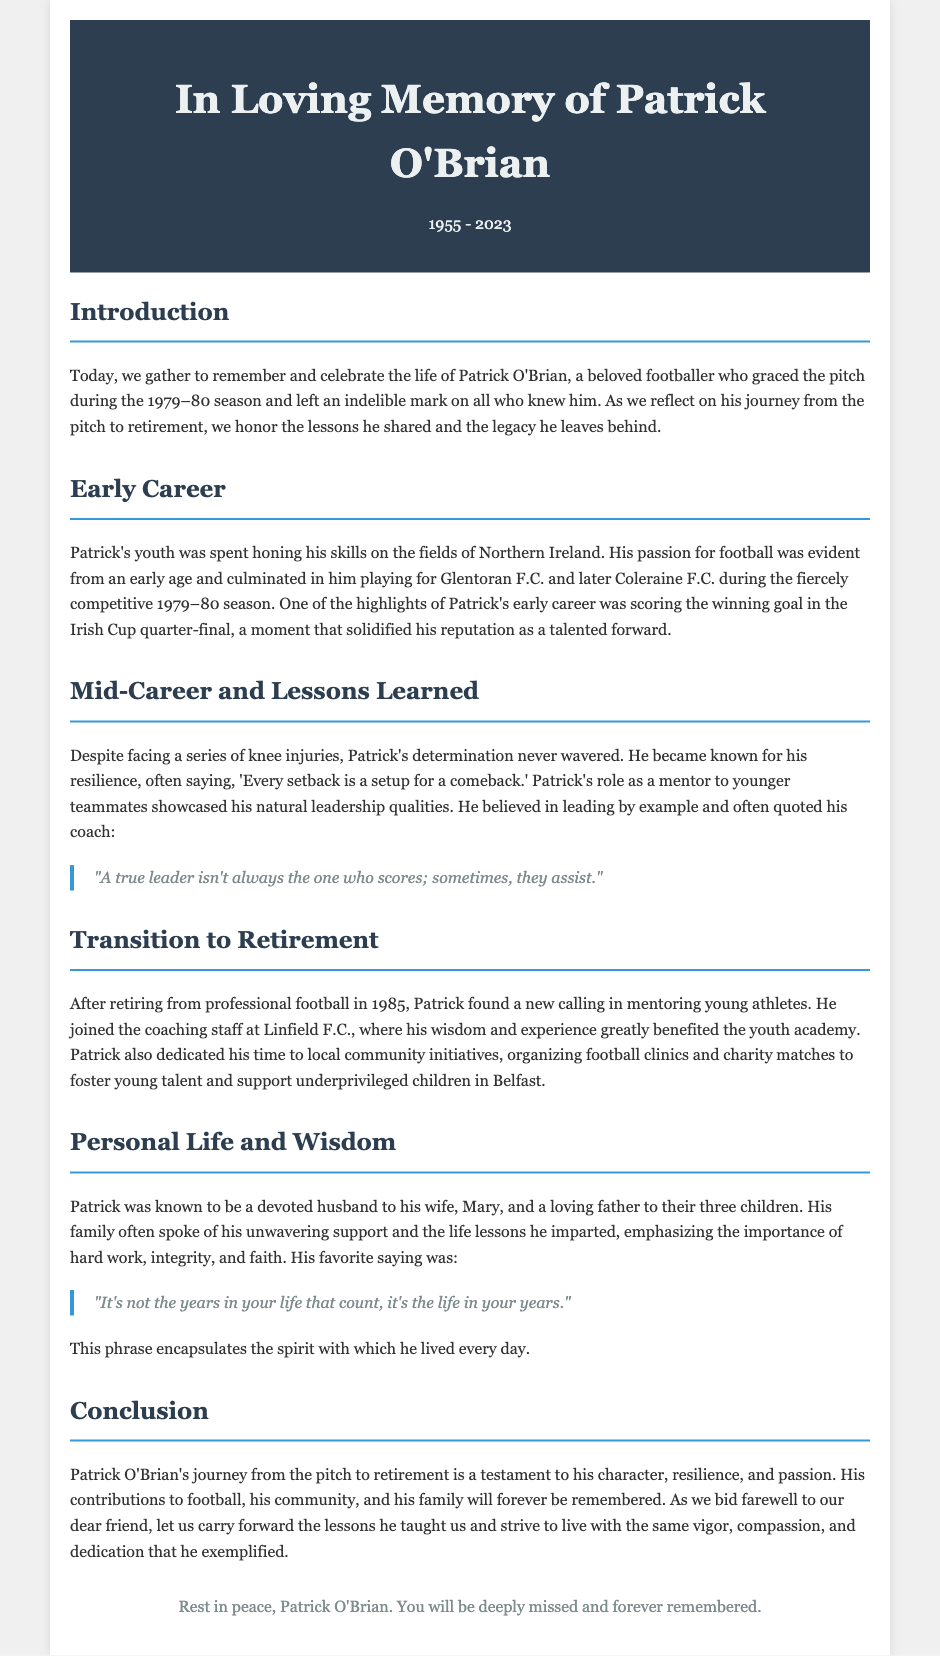What is the full name of the individual being remembered? The document provides the name of the individual, which is stated in the header.
Answer: Patrick O'Brian In which year did Patrick O'Brian play during the competitive season? The document mentions the specific season in the introductory section.
Answer: 1979–80 What was Patrick's role during his football career? The document describes Patrick's position on the field as a forward in his early career.
Answer: Forward What injury did Patrick face during his career? The document specifies the type of injuries Patrick dealt with that impacted his playing.
Answer: Knee injuries What quote did Patrick often say regarding setbacks? The document includes a specific quote attributed to Patrick about setbacks and comebacks.
Answer: "Every setback is a setup for a comeback." What did Patrick dedicate his time to after retiring from football? The document outlines Patrick's main focus after retirement, particularly in mentoring young athletes.
Answer: Mentoring young athletes Who was Patrick O'Brian's wife? The document recognizes Patrick's family as part of his personal life, including his spouse.
Answer: Mary What did Patrick consider important in life, as per his favorite saying? The document mentions a saying that encapsulates Patrick's view on life and its importance.
Answer: "It's not the years in your life that count, it's the life in your years." What is the document's purpose? The document serves a specific function of celebrating a person's life and contributions, as indicated in the introduction.
Answer: Eulogy 